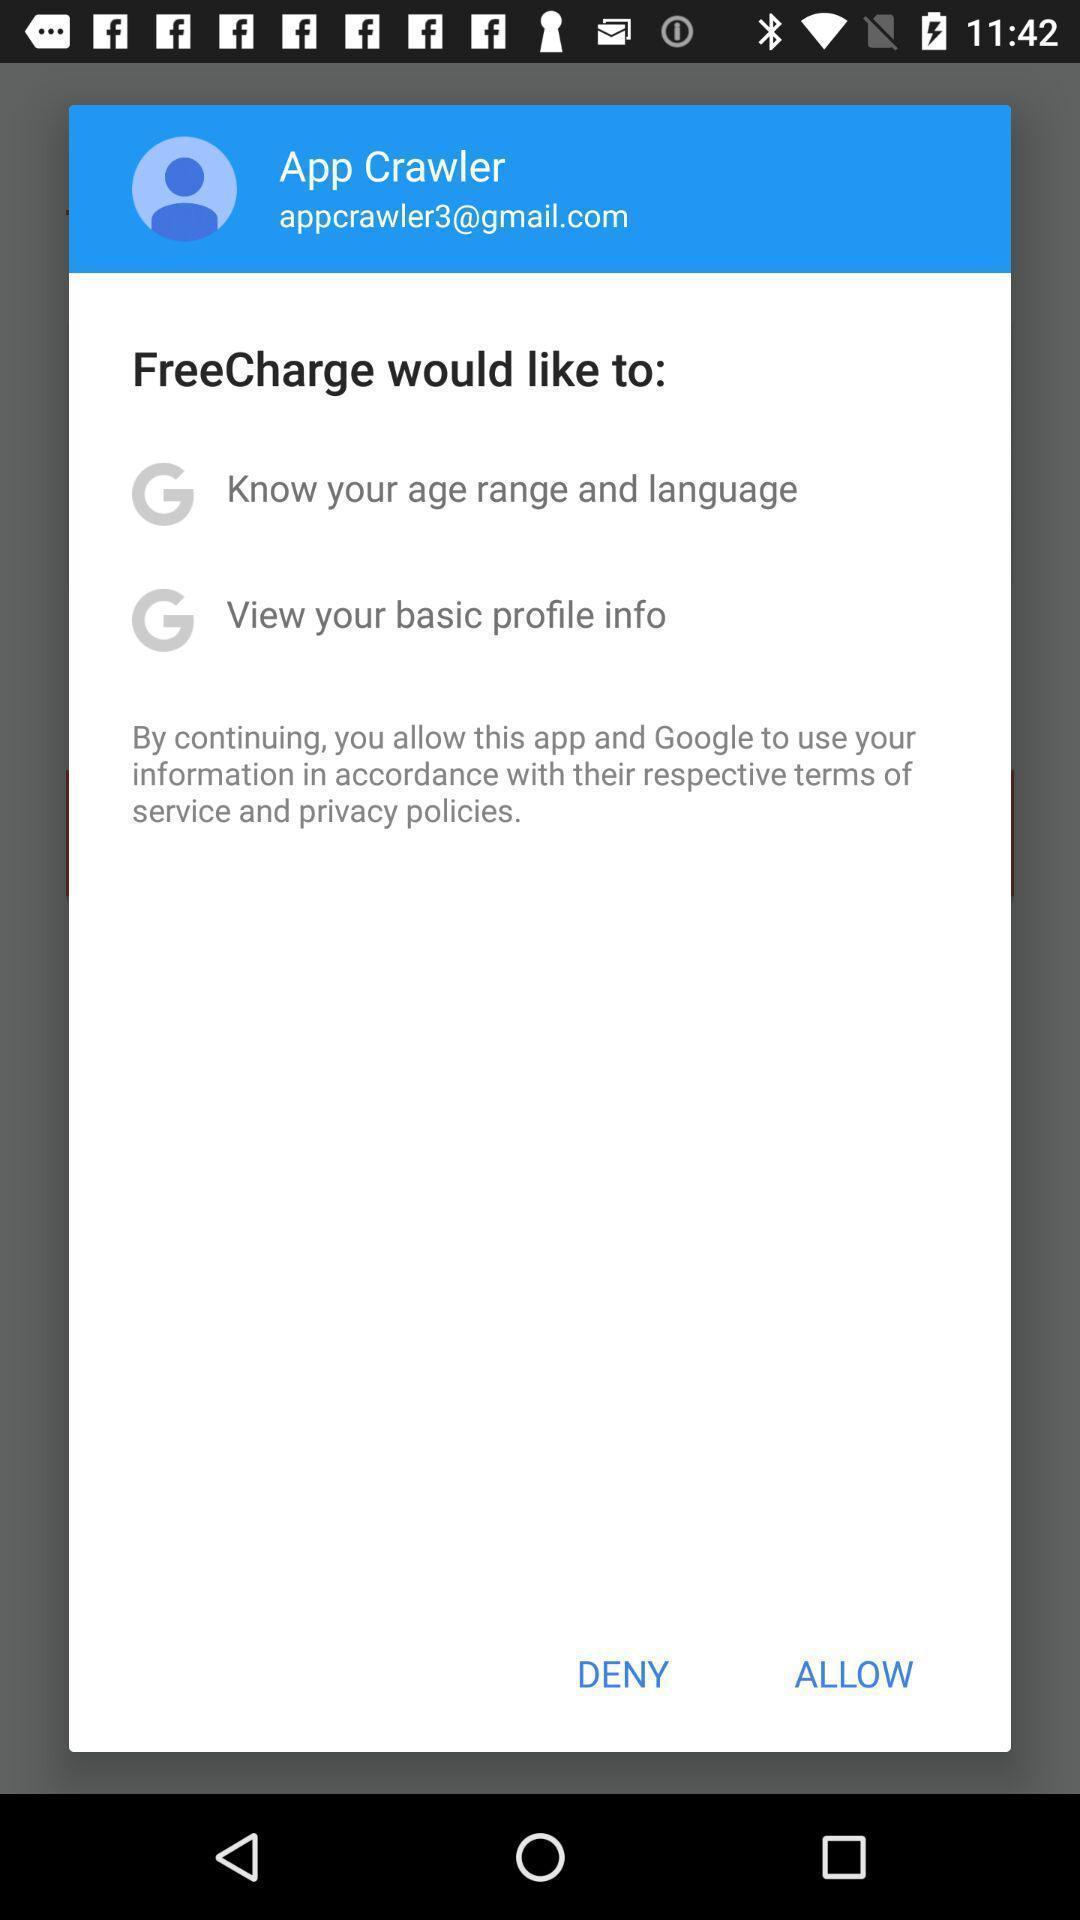Provide a detailed account of this screenshot. Popup to allow in the mobile recharge app. 